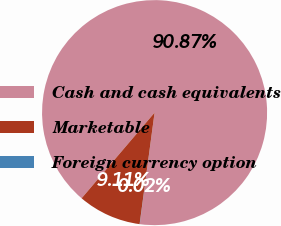Convert chart. <chart><loc_0><loc_0><loc_500><loc_500><pie_chart><fcel>Cash and cash equivalents<fcel>Marketable<fcel>Foreign currency option<nl><fcel>90.87%<fcel>9.11%<fcel>0.02%<nl></chart> 